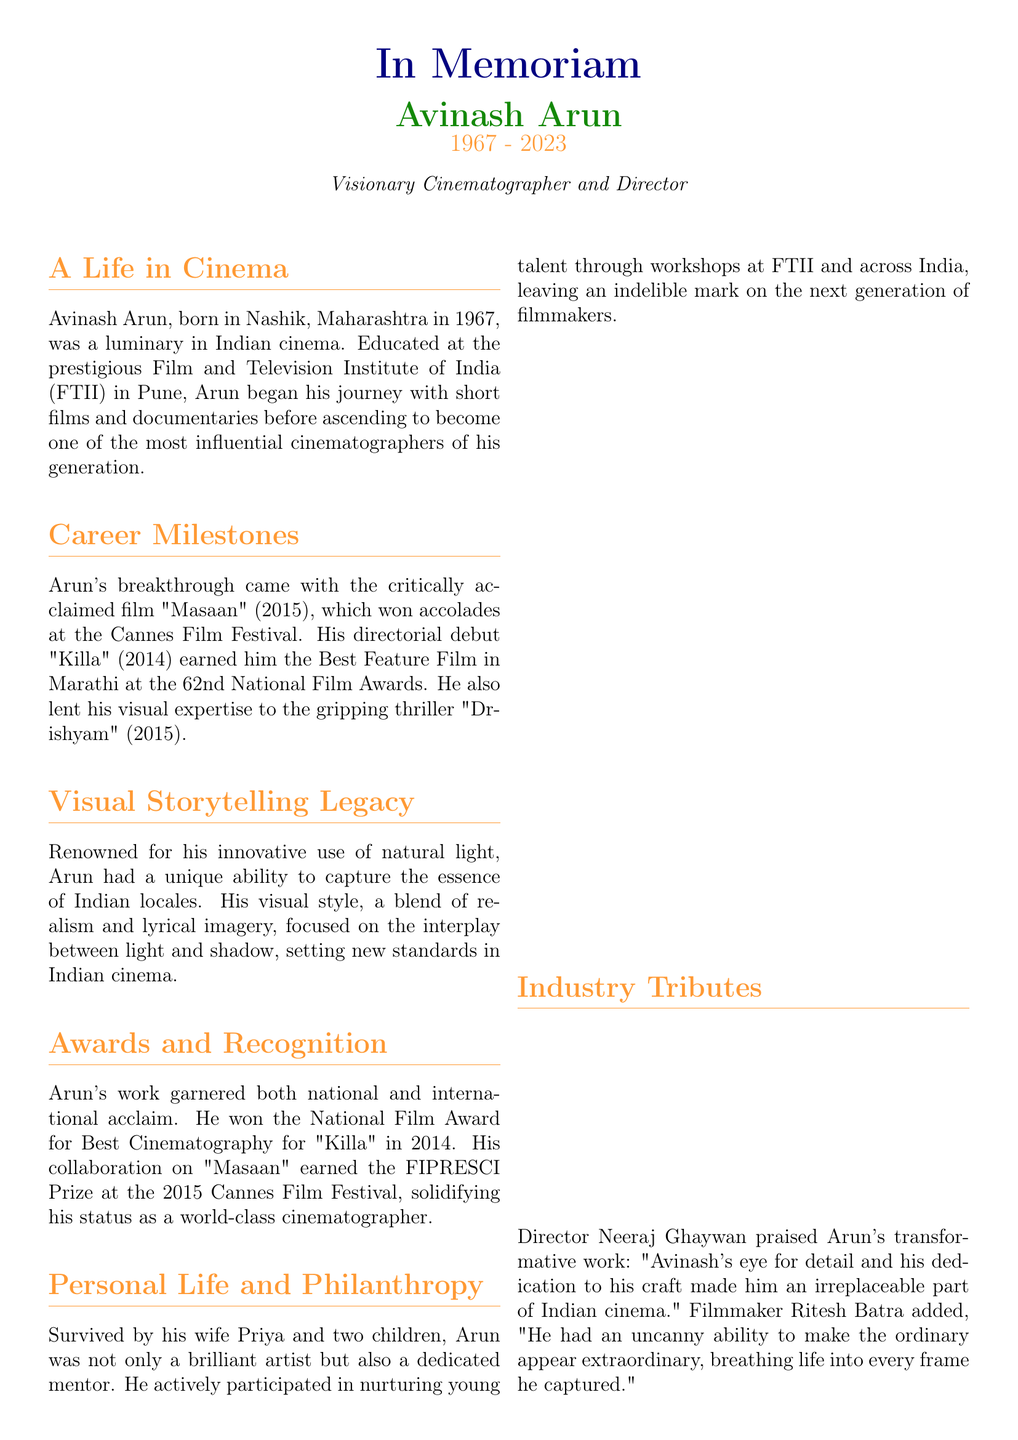What was Avinash Arun's profession? The document states that Avinash Arun was a visionary cinematographer and director.
Answer: Cinematographer and Director When was Avinash Arun born? The document provides his birth year as 1967.
Answer: 1967 Which film marked Avinash Arun's directorial debut? The document mentions that his directorial debut was "Killa."
Answer: Killa What notable award did Arun win for "Killa"? The document states he won the Best Feature Film in Marathi at the 62nd National Film Awards for "Killa."
Answer: Best Feature Film in Marathi What is the name of Avinash Arun's wife? The document indicates that his wife's name is Priya.
Answer: Priya Which festival recognized "Masaan" that featured Avinash Arun's cinematography? The document mentions that "Masaan" won accolades at the Cannes Film Festival.
Answer: Cannes Film Festival What does the document cite as Avinash Arun's unique visual storytelling technique? The document explains he was renowned for his innovative use of natural light.
Answer: Innovative use of natural light How many children did Avinash Arun have? The document states he is survived by two children.
Answer: Two Who praised Avinash Arun's work in the document? The document includes tributes from directors Neeraj Ghaywan and Ritesh Batra.
Answer: Neeraj Ghaywan and Ritesh Batra 